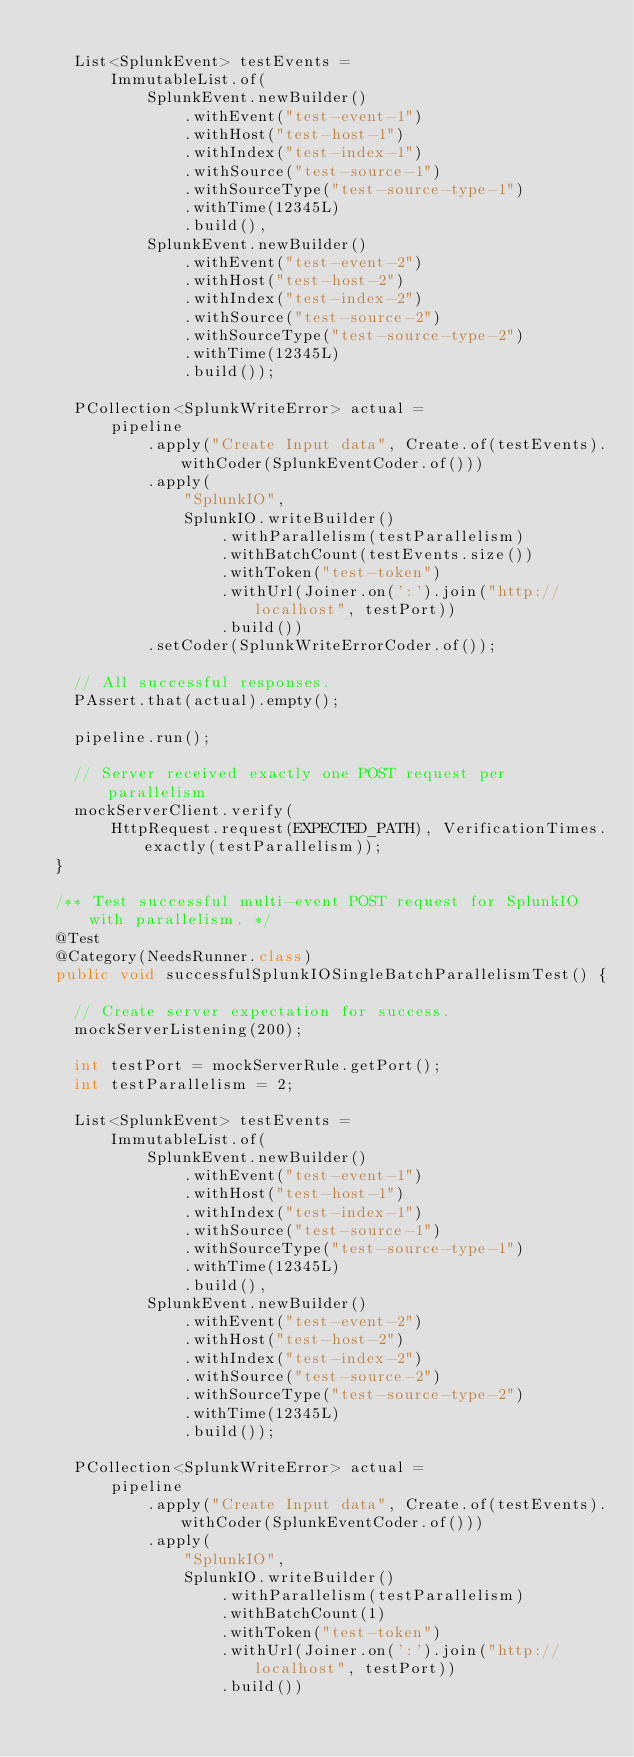Convert code to text. <code><loc_0><loc_0><loc_500><loc_500><_Java_>
    List<SplunkEvent> testEvents =
        ImmutableList.of(
            SplunkEvent.newBuilder()
                .withEvent("test-event-1")
                .withHost("test-host-1")
                .withIndex("test-index-1")
                .withSource("test-source-1")
                .withSourceType("test-source-type-1")
                .withTime(12345L)
                .build(),
            SplunkEvent.newBuilder()
                .withEvent("test-event-2")
                .withHost("test-host-2")
                .withIndex("test-index-2")
                .withSource("test-source-2")
                .withSourceType("test-source-type-2")
                .withTime(12345L)
                .build());

    PCollection<SplunkWriteError> actual =
        pipeline
            .apply("Create Input data", Create.of(testEvents).withCoder(SplunkEventCoder.of()))
            .apply(
                "SplunkIO",
                SplunkIO.writeBuilder()
                    .withParallelism(testParallelism)
                    .withBatchCount(testEvents.size())
                    .withToken("test-token")
                    .withUrl(Joiner.on(':').join("http://localhost", testPort))
                    .build())
            .setCoder(SplunkWriteErrorCoder.of());

    // All successful responses.
    PAssert.that(actual).empty();

    pipeline.run();

    // Server received exactly one POST request per parallelism
    mockServerClient.verify(
        HttpRequest.request(EXPECTED_PATH), VerificationTimes.exactly(testParallelism));
  }

  /** Test successful multi-event POST request for SplunkIO with parallelism. */
  @Test
  @Category(NeedsRunner.class)
  public void successfulSplunkIOSingleBatchParallelismTest() {

    // Create server expectation for success.
    mockServerListening(200);

    int testPort = mockServerRule.getPort();
    int testParallelism = 2;

    List<SplunkEvent> testEvents =
        ImmutableList.of(
            SplunkEvent.newBuilder()
                .withEvent("test-event-1")
                .withHost("test-host-1")
                .withIndex("test-index-1")
                .withSource("test-source-1")
                .withSourceType("test-source-type-1")
                .withTime(12345L)
                .build(),
            SplunkEvent.newBuilder()
                .withEvent("test-event-2")
                .withHost("test-host-2")
                .withIndex("test-index-2")
                .withSource("test-source-2")
                .withSourceType("test-source-type-2")
                .withTime(12345L)
                .build());

    PCollection<SplunkWriteError> actual =
        pipeline
            .apply("Create Input data", Create.of(testEvents).withCoder(SplunkEventCoder.of()))
            .apply(
                "SplunkIO",
                SplunkIO.writeBuilder()
                    .withParallelism(testParallelism)
                    .withBatchCount(1)
                    .withToken("test-token")
                    .withUrl(Joiner.on(':').join("http://localhost", testPort))
                    .build())</code> 